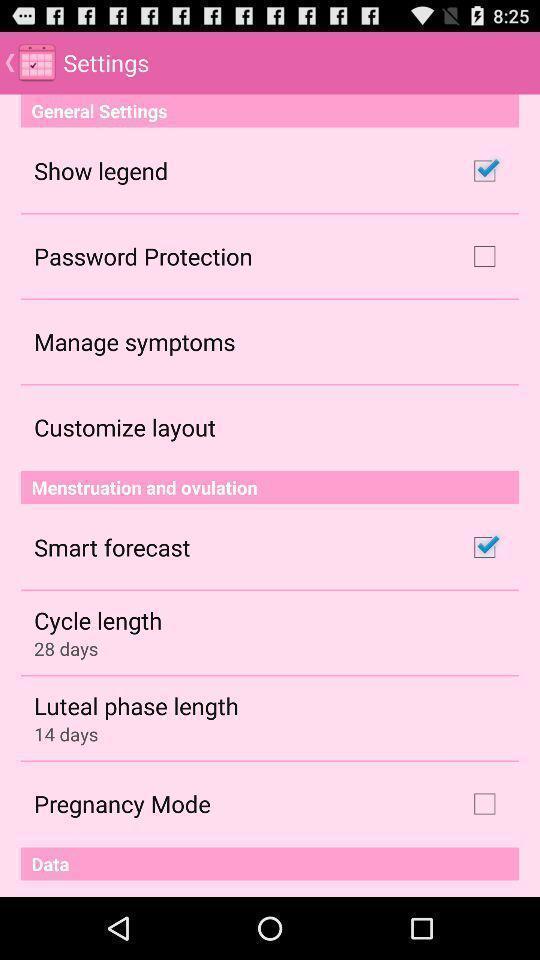Give me a narrative description of this picture. Settings page. 